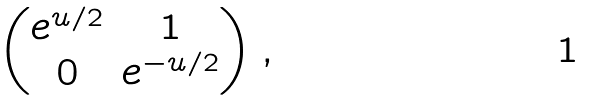<formula> <loc_0><loc_0><loc_500><loc_500>\begin{pmatrix} e ^ { u / 2 } & 1 \\ 0 & e ^ { - u / 2 } \end{pmatrix} ,</formula> 